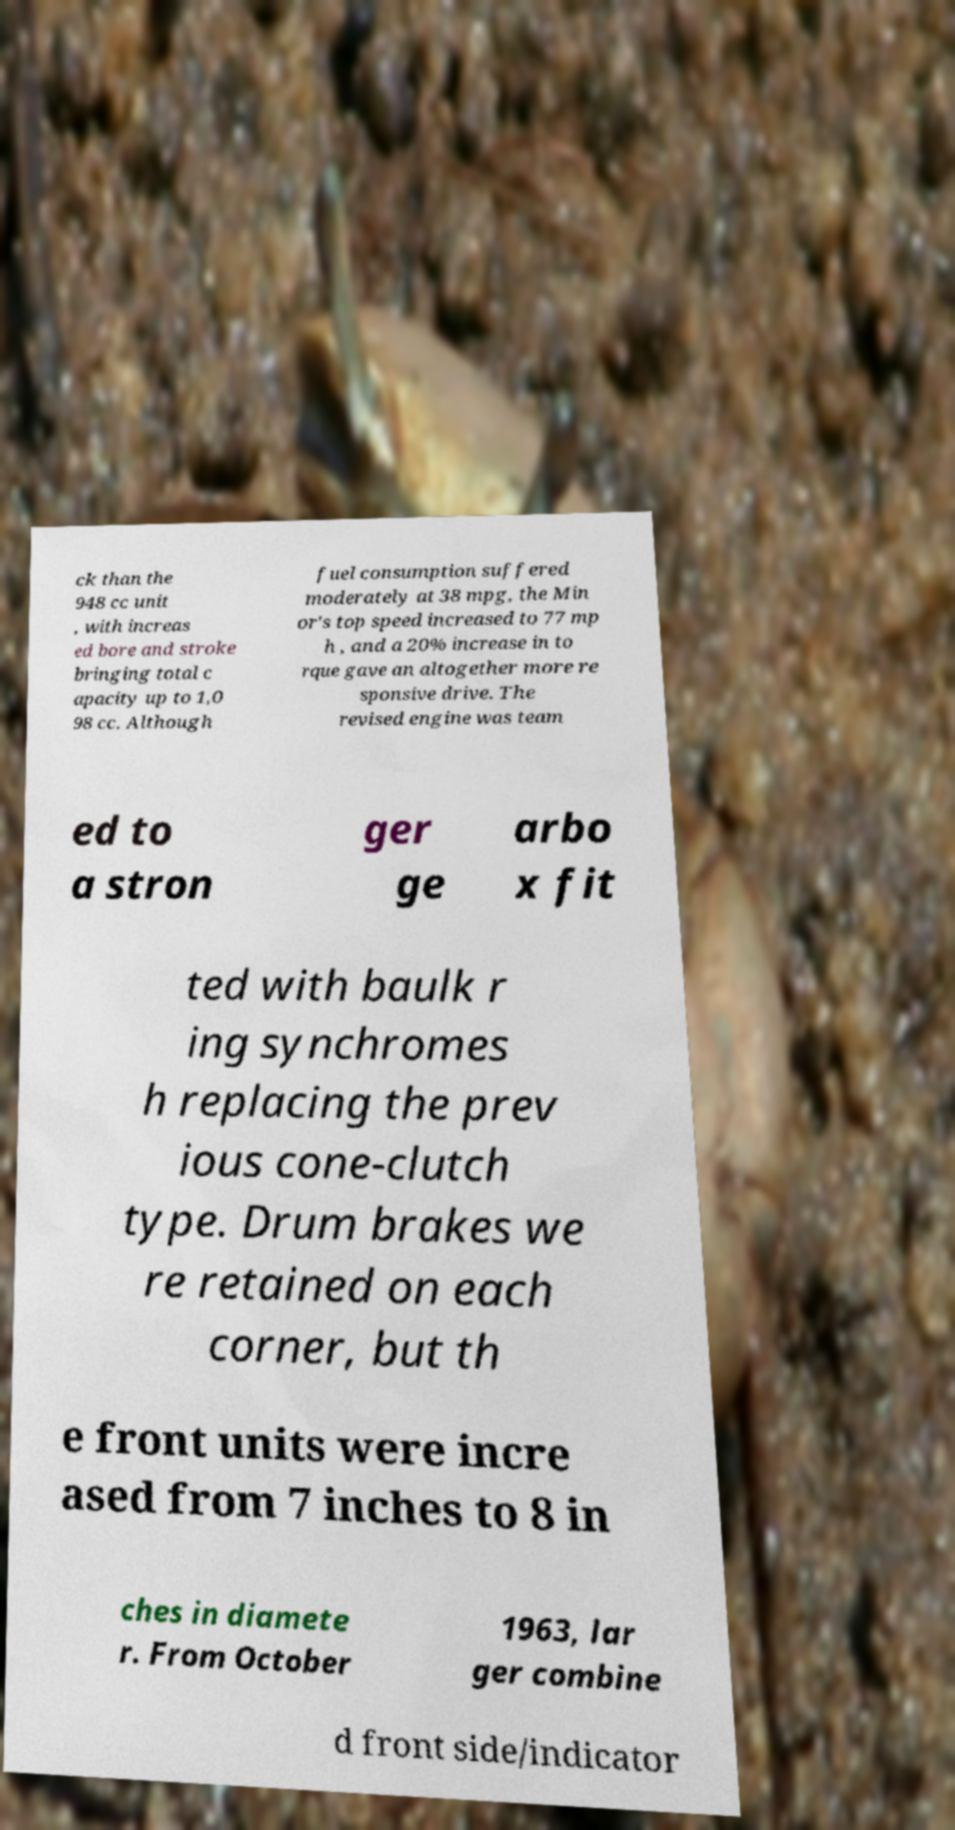Could you extract and type out the text from this image? ck than the 948 cc unit , with increas ed bore and stroke bringing total c apacity up to 1,0 98 cc. Although fuel consumption suffered moderately at 38 mpg, the Min or's top speed increased to 77 mp h , and a 20% increase in to rque gave an altogether more re sponsive drive. The revised engine was team ed to a stron ger ge arbo x fit ted with baulk r ing synchromes h replacing the prev ious cone-clutch type. Drum brakes we re retained on each corner, but th e front units were incre ased from 7 inches to 8 in ches in diamete r. From October 1963, lar ger combine d front side/indicator 